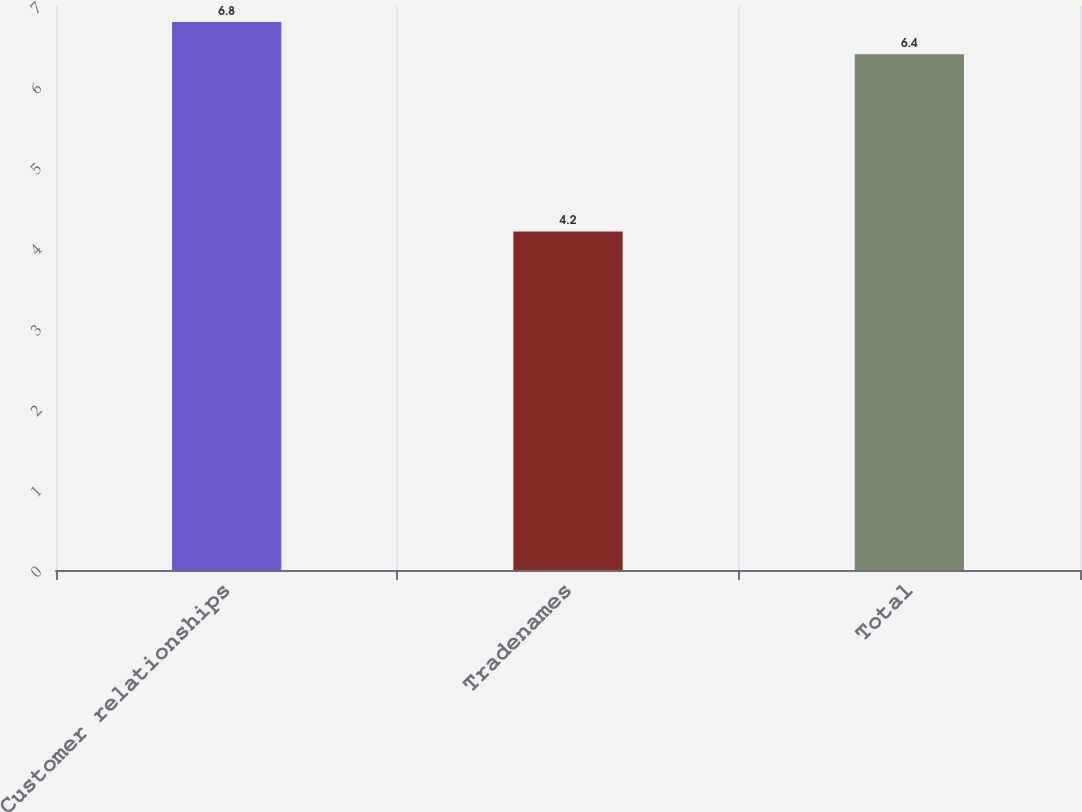Convert chart to OTSL. <chart><loc_0><loc_0><loc_500><loc_500><bar_chart><fcel>Customer relationships<fcel>Tradenames<fcel>Total<nl><fcel>6.8<fcel>4.2<fcel>6.4<nl></chart> 